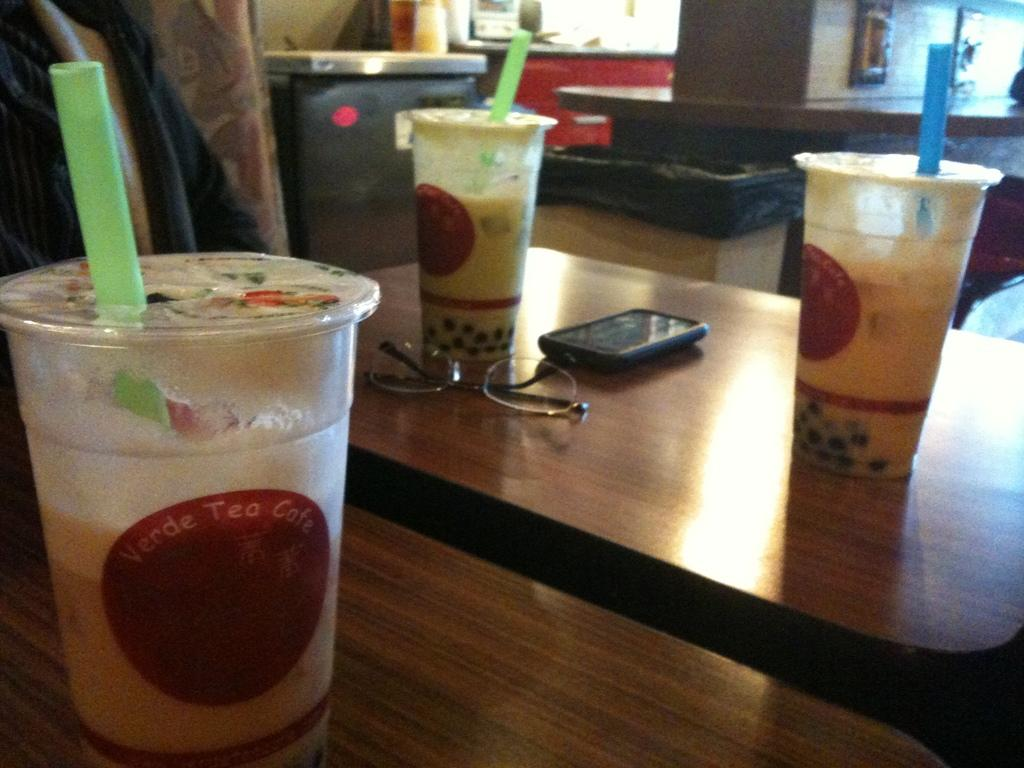<image>
Give a short and clear explanation of the subsequent image. 3 Cups of tea from the Verde Tea Cafe sit on wooden tables. 